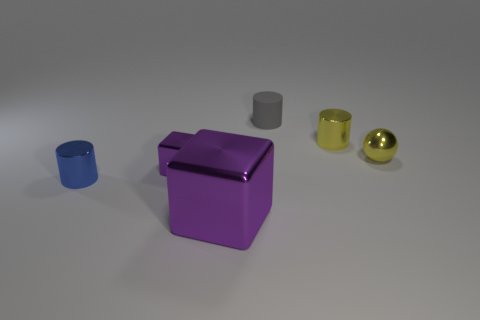Add 3 small shiny cylinders. How many objects exist? 9 Subtract all cubes. How many objects are left? 4 Subtract all large blue matte cylinders. Subtract all big blocks. How many objects are left? 5 Add 4 yellow metallic balls. How many yellow metallic balls are left? 5 Add 1 tiny yellow spheres. How many tiny yellow spheres exist? 2 Subtract 0 blue spheres. How many objects are left? 6 